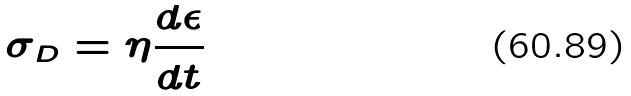Convert formula to latex. <formula><loc_0><loc_0><loc_500><loc_500>\sigma _ { D } = \eta \frac { d \epsilon } { d t }</formula> 